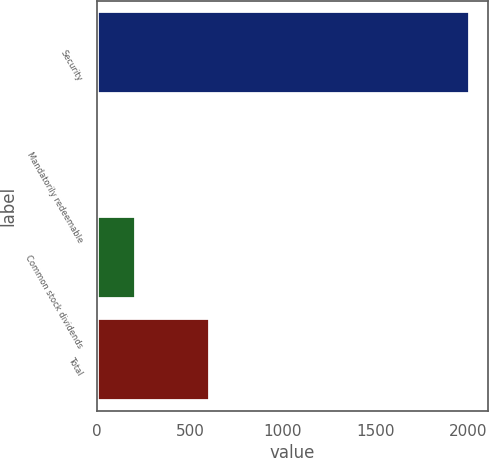Convert chart to OTSL. <chart><loc_0><loc_0><loc_500><loc_500><bar_chart><fcel>Security<fcel>Mandatorily redeemable<fcel>Common stock dividends<fcel>Total<nl><fcel>2004<fcel>1<fcel>201.3<fcel>601.9<nl></chart> 